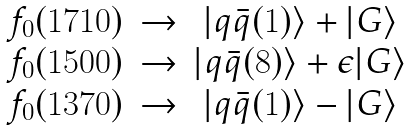Convert formula to latex. <formula><loc_0><loc_0><loc_500><loc_500>\begin{array} { c c c } f _ { 0 } ( 1 7 1 0 ) & \rightarrow & | q \bar { q } ( 1 ) \rangle + | G \rangle \\ f _ { 0 } ( 1 5 0 0 ) & \rightarrow & | q \bar { q } ( 8 ) \rangle + \epsilon | G \rangle \\ f _ { 0 } ( 1 3 7 0 ) & \rightarrow & | q \bar { q } ( 1 ) \rangle - | G \rangle \\ \end{array}</formula> 